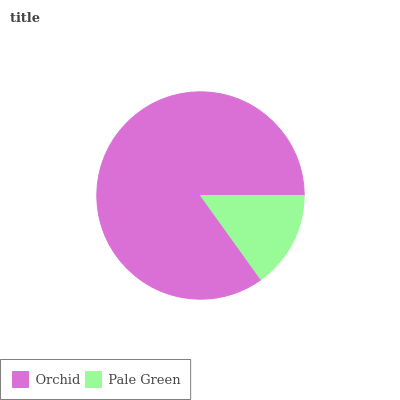Is Pale Green the minimum?
Answer yes or no. Yes. Is Orchid the maximum?
Answer yes or no. Yes. Is Pale Green the maximum?
Answer yes or no. No. Is Orchid greater than Pale Green?
Answer yes or no. Yes. Is Pale Green less than Orchid?
Answer yes or no. Yes. Is Pale Green greater than Orchid?
Answer yes or no. No. Is Orchid less than Pale Green?
Answer yes or no. No. Is Orchid the high median?
Answer yes or no. Yes. Is Pale Green the low median?
Answer yes or no. Yes. Is Pale Green the high median?
Answer yes or no. No. Is Orchid the low median?
Answer yes or no. No. 